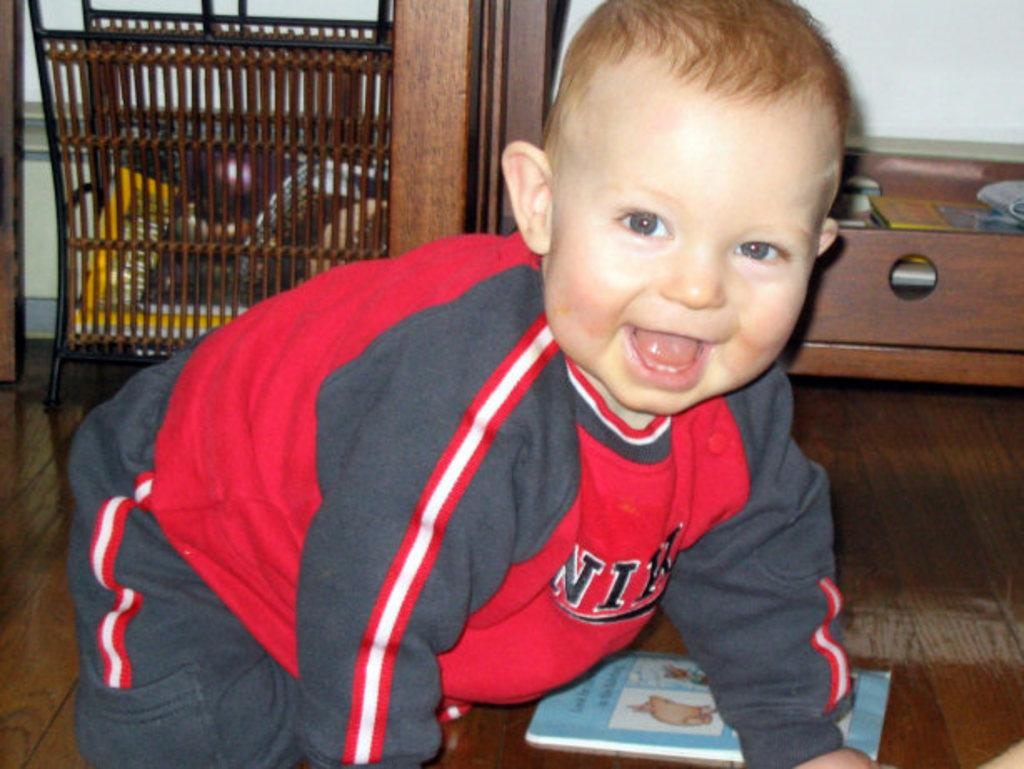<image>
Provide a brief description of the given image. a baby crawling around the ground the the letter N on it 